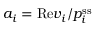<formula> <loc_0><loc_0><loc_500><loc_500>a _ { i } = R e v _ { i } / p _ { i } ^ { s s }</formula> 